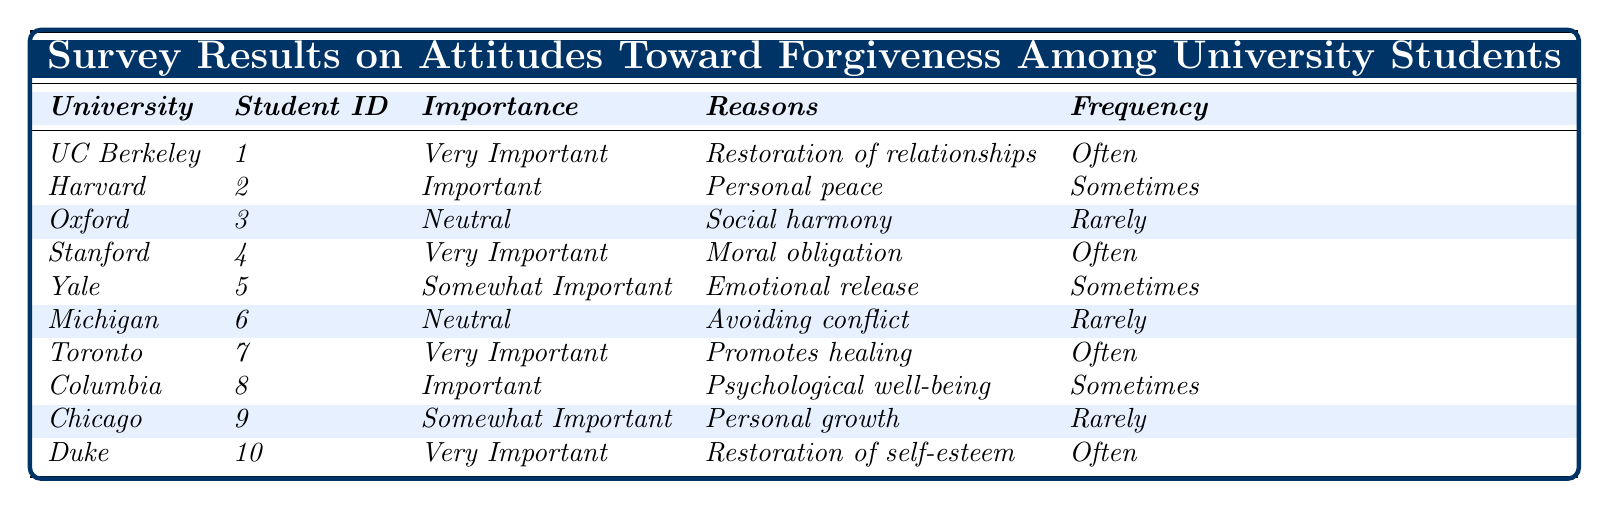What is the forgiveness importance rating for the University of Toronto? The table indicates that the University of Toronto has a forgiveness importance rating categorized as "Very Important."
Answer: Very Important How many universities rated forgiveness as "Very Important"? There are 4 universities (UC Berkeley, Stanford, Toronto, Duke) that rated forgiveness as "Very Important."
Answer: 4 Which university emphasizes "Restoration of relationships" as a reason for forgiveness? The table shows that UC Berkeley emphasizes "Restoration of relationships" as a reason for forgiveness.
Answer: University of California, Berkeley What is the frequency of practicing forgiveness for students who rated it as "Somewhat Important"? Both Yale and Chicago rated forgiveness as "Somewhat Important," and their frequency of practicing forgiveness is "Sometimes" and "Rarely," respectively.
Answer: Yale: Sometimes; Chicago: Rarely Is it true that all students who rated forgiveness as "Very Important" practice it often? No, it is not true. While UC Berkeley, Stanford, Toronto, and Duke rated it as "Very Important," UC Berkeley, Stanford, and Duke practice it often, but Toronto practices it often as well, confirming the statement is partially true.
Answer: No What percentage of students from the table practice forgiveness "Often"? There are 4 students (UC Berkeley, Stanford, Toronto, Duke) out of 10 total, which gives a percentage of (4/10)*100 = 40%.
Answer: 40% Which reason for forgiveness is the least cited among the responses? The reason "Avoiding conflict" from the University of Michigan and "Personal growth" from the University of Chicago are both cited the least frequently, with only one occurrence each.
Answer: Avoiding conflict, Personal growth How does the frequency of practicing forgiveness differ between universities rated "Neutral"? For the universities rated "Neutral," the University of Oxford practices forgiveness "Rarely," and the University of Michigan practices it "Rarely" as well. There is no difference as both practice it rarely.
Answer: No difference What is the general attitude toward forgiveness based on the table? The general attitude shows that while some students rate forgiveness as very important, there are also many students who view it as neutral or only somewhat important, indicating a diverse perspective on forgiveness.
Answer: Diverse perspectives Which university has students that practice forgiveness "Sometimes"? Harvard University and Yale University have students who practice forgiveness "Sometimes," according to the table.
Answer: Harvard University, Yale University 